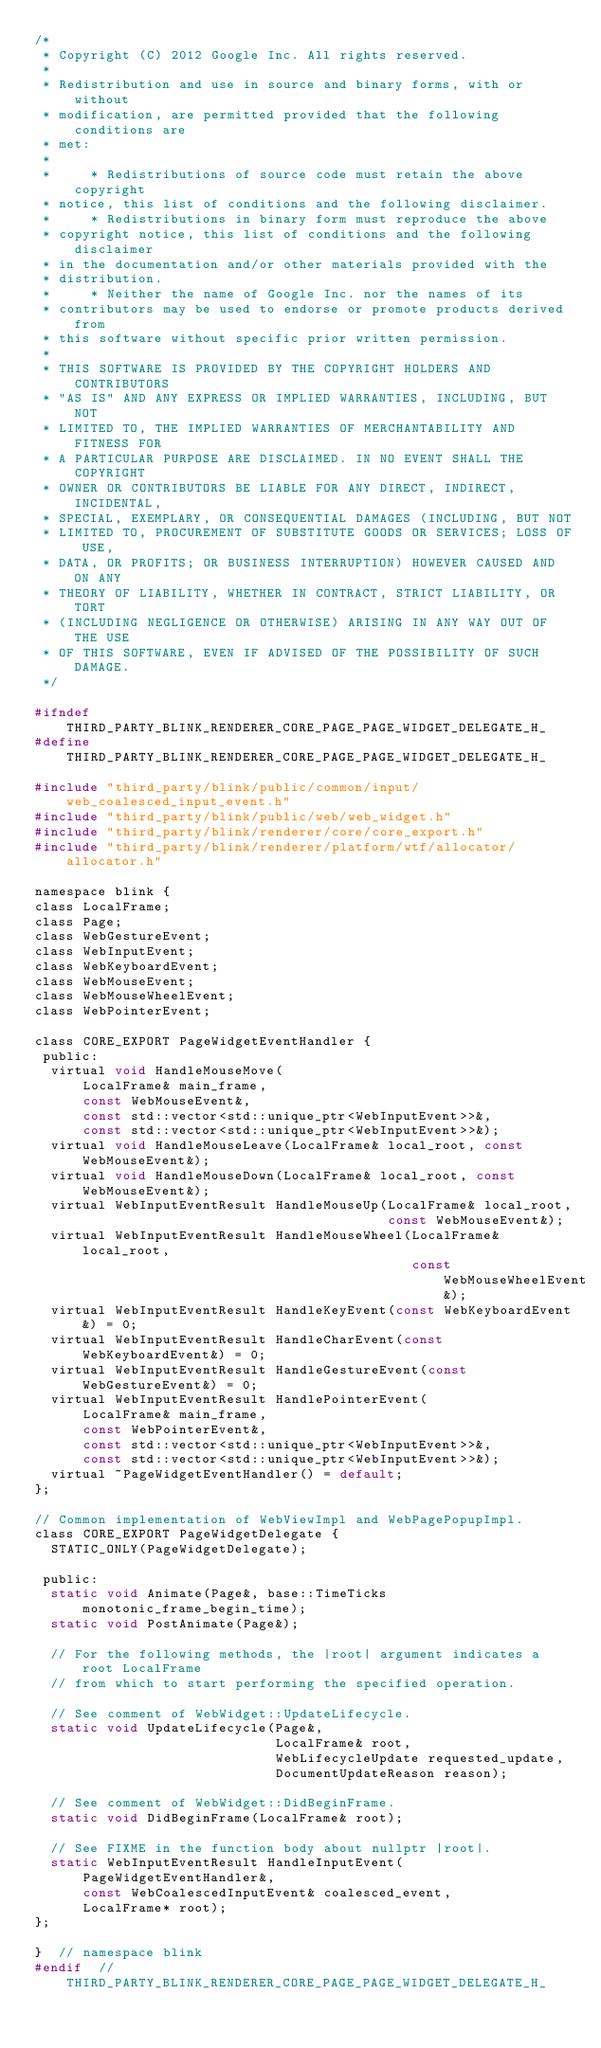Convert code to text. <code><loc_0><loc_0><loc_500><loc_500><_C_>/*
 * Copyright (C) 2012 Google Inc. All rights reserved.
 *
 * Redistribution and use in source and binary forms, with or without
 * modification, are permitted provided that the following conditions are
 * met:
 *
 *     * Redistributions of source code must retain the above copyright
 * notice, this list of conditions and the following disclaimer.
 *     * Redistributions in binary form must reproduce the above
 * copyright notice, this list of conditions and the following disclaimer
 * in the documentation and/or other materials provided with the
 * distribution.
 *     * Neither the name of Google Inc. nor the names of its
 * contributors may be used to endorse or promote products derived from
 * this software without specific prior written permission.
 *
 * THIS SOFTWARE IS PROVIDED BY THE COPYRIGHT HOLDERS AND CONTRIBUTORS
 * "AS IS" AND ANY EXPRESS OR IMPLIED WARRANTIES, INCLUDING, BUT NOT
 * LIMITED TO, THE IMPLIED WARRANTIES OF MERCHANTABILITY AND FITNESS FOR
 * A PARTICULAR PURPOSE ARE DISCLAIMED. IN NO EVENT SHALL THE COPYRIGHT
 * OWNER OR CONTRIBUTORS BE LIABLE FOR ANY DIRECT, INDIRECT, INCIDENTAL,
 * SPECIAL, EXEMPLARY, OR CONSEQUENTIAL DAMAGES (INCLUDING, BUT NOT
 * LIMITED TO, PROCUREMENT OF SUBSTITUTE GOODS OR SERVICES; LOSS OF USE,
 * DATA, OR PROFITS; OR BUSINESS INTERRUPTION) HOWEVER CAUSED AND ON ANY
 * THEORY OF LIABILITY, WHETHER IN CONTRACT, STRICT LIABILITY, OR TORT
 * (INCLUDING NEGLIGENCE OR OTHERWISE) ARISING IN ANY WAY OUT OF THE USE
 * OF THIS SOFTWARE, EVEN IF ADVISED OF THE POSSIBILITY OF SUCH DAMAGE.
 */

#ifndef THIRD_PARTY_BLINK_RENDERER_CORE_PAGE_PAGE_WIDGET_DELEGATE_H_
#define THIRD_PARTY_BLINK_RENDERER_CORE_PAGE_PAGE_WIDGET_DELEGATE_H_

#include "third_party/blink/public/common/input/web_coalesced_input_event.h"
#include "third_party/blink/public/web/web_widget.h"
#include "third_party/blink/renderer/core/core_export.h"
#include "third_party/blink/renderer/platform/wtf/allocator/allocator.h"

namespace blink {
class LocalFrame;
class Page;
class WebGestureEvent;
class WebInputEvent;
class WebKeyboardEvent;
class WebMouseEvent;
class WebMouseWheelEvent;
class WebPointerEvent;

class CORE_EXPORT PageWidgetEventHandler {
 public:
  virtual void HandleMouseMove(
      LocalFrame& main_frame,
      const WebMouseEvent&,
      const std::vector<std::unique_ptr<WebInputEvent>>&,
      const std::vector<std::unique_ptr<WebInputEvent>>&);
  virtual void HandleMouseLeave(LocalFrame& local_root, const WebMouseEvent&);
  virtual void HandleMouseDown(LocalFrame& local_root, const WebMouseEvent&);
  virtual WebInputEventResult HandleMouseUp(LocalFrame& local_root,
                                            const WebMouseEvent&);
  virtual WebInputEventResult HandleMouseWheel(LocalFrame& local_root,
                                               const WebMouseWheelEvent&);
  virtual WebInputEventResult HandleKeyEvent(const WebKeyboardEvent&) = 0;
  virtual WebInputEventResult HandleCharEvent(const WebKeyboardEvent&) = 0;
  virtual WebInputEventResult HandleGestureEvent(const WebGestureEvent&) = 0;
  virtual WebInputEventResult HandlePointerEvent(
      LocalFrame& main_frame,
      const WebPointerEvent&,
      const std::vector<std::unique_ptr<WebInputEvent>>&,
      const std::vector<std::unique_ptr<WebInputEvent>>&);
  virtual ~PageWidgetEventHandler() = default;
};

// Common implementation of WebViewImpl and WebPagePopupImpl.
class CORE_EXPORT PageWidgetDelegate {
  STATIC_ONLY(PageWidgetDelegate);

 public:
  static void Animate(Page&, base::TimeTicks monotonic_frame_begin_time);
  static void PostAnimate(Page&);

  // For the following methods, the |root| argument indicates a root LocalFrame
  // from which to start performing the specified operation.

  // See comment of WebWidget::UpdateLifecycle.
  static void UpdateLifecycle(Page&,
                              LocalFrame& root,
                              WebLifecycleUpdate requested_update,
                              DocumentUpdateReason reason);

  // See comment of WebWidget::DidBeginFrame.
  static void DidBeginFrame(LocalFrame& root);

  // See FIXME in the function body about nullptr |root|.
  static WebInputEventResult HandleInputEvent(
      PageWidgetEventHandler&,
      const WebCoalescedInputEvent& coalesced_event,
      LocalFrame* root);
};

}  // namespace blink
#endif  // THIRD_PARTY_BLINK_RENDERER_CORE_PAGE_PAGE_WIDGET_DELEGATE_H_
</code> 